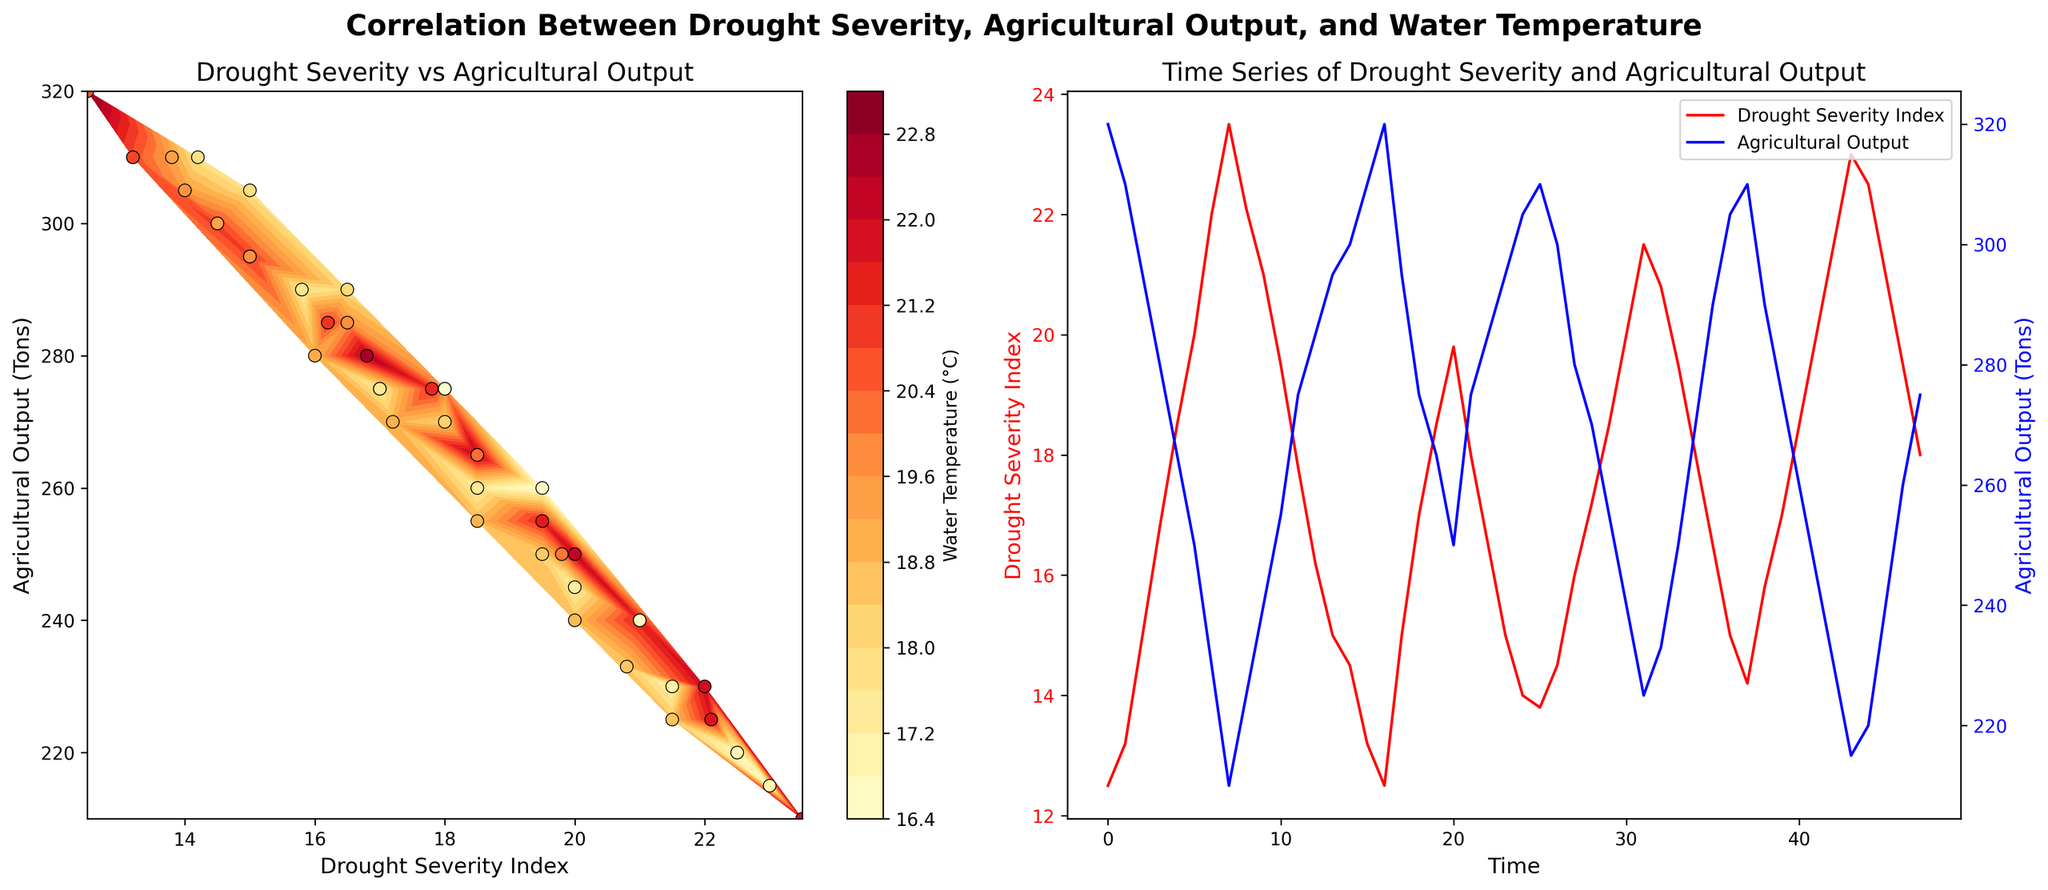What's the title of the first subplot? The title of the first subplot is written at the top of the respective plot. It helps to understand what the specific chart is about.
Answer: Drought Severity vs Agricultural Output What variables are plotted on the x and y axes in the first subplot? The x-axis represents the Drought Severity Index and the y-axis represents Agricultural Output in tons, as indicated by the axis labels.
Answer: Drought Severity Index on x, Agricultural Output on y How does the color indicate water temperature in the second subplot? In the first subplot, the color gradient represents water temperature, shown by the color bar on the right. Warmer colors indicate higher temperatures.
Answer: Using a color gradient from yellow to red Which month shows the highest drought severity index? By checking the time series in the second subplot, we can identify the month with the highest peak in the red line representing the drought severity index.
Answer: August 2019 When was the Agricultural Output at its lowest? By analyzing the blue line in the second subplot, we can see when it dips to its lowest point, indicating the minimum agricultural output in tons.
Answer: August 2019 How do drought severity and agricultural output correlate over time? By visually examining the second subplot, one can observe if the red line (drought severity) trends inversely with the blue line (agricultural output), indicating a negative correlation.
Answer: Inversely correlated How does drought severity impact agricultural output according to the first subplot? The scatter plot in the first subplot with a trend line direction shows that as drought severity (x-axis) increases, agricultural output (y-axis) generally decreases, suggesting a negative impact.
Answer: Agricultural output decreases with higher drought severity What is the agricultural output range in the data? On the y-axis of both subplots, the minimum and maximum values of agricultural output can be identified within the plotted points and the time series data ranges.
Answer: 210 - 320 tons What's the trend of water temperature over the years? Using the color gradient in the first plot or the y-axis values from the data, one can infer the change in water use temperature over time, observing if it shows an increasing or decreasing trend.
Answer: Decreasing Which subplot shows a clear seasonal pattern in drought severity? The second subplot with the time series plot clearly illustrates seasonal variations over multiple years, exhibiting repeated patterns in drought severity indices typically aligned with specific months.
Answer: The second subplot 